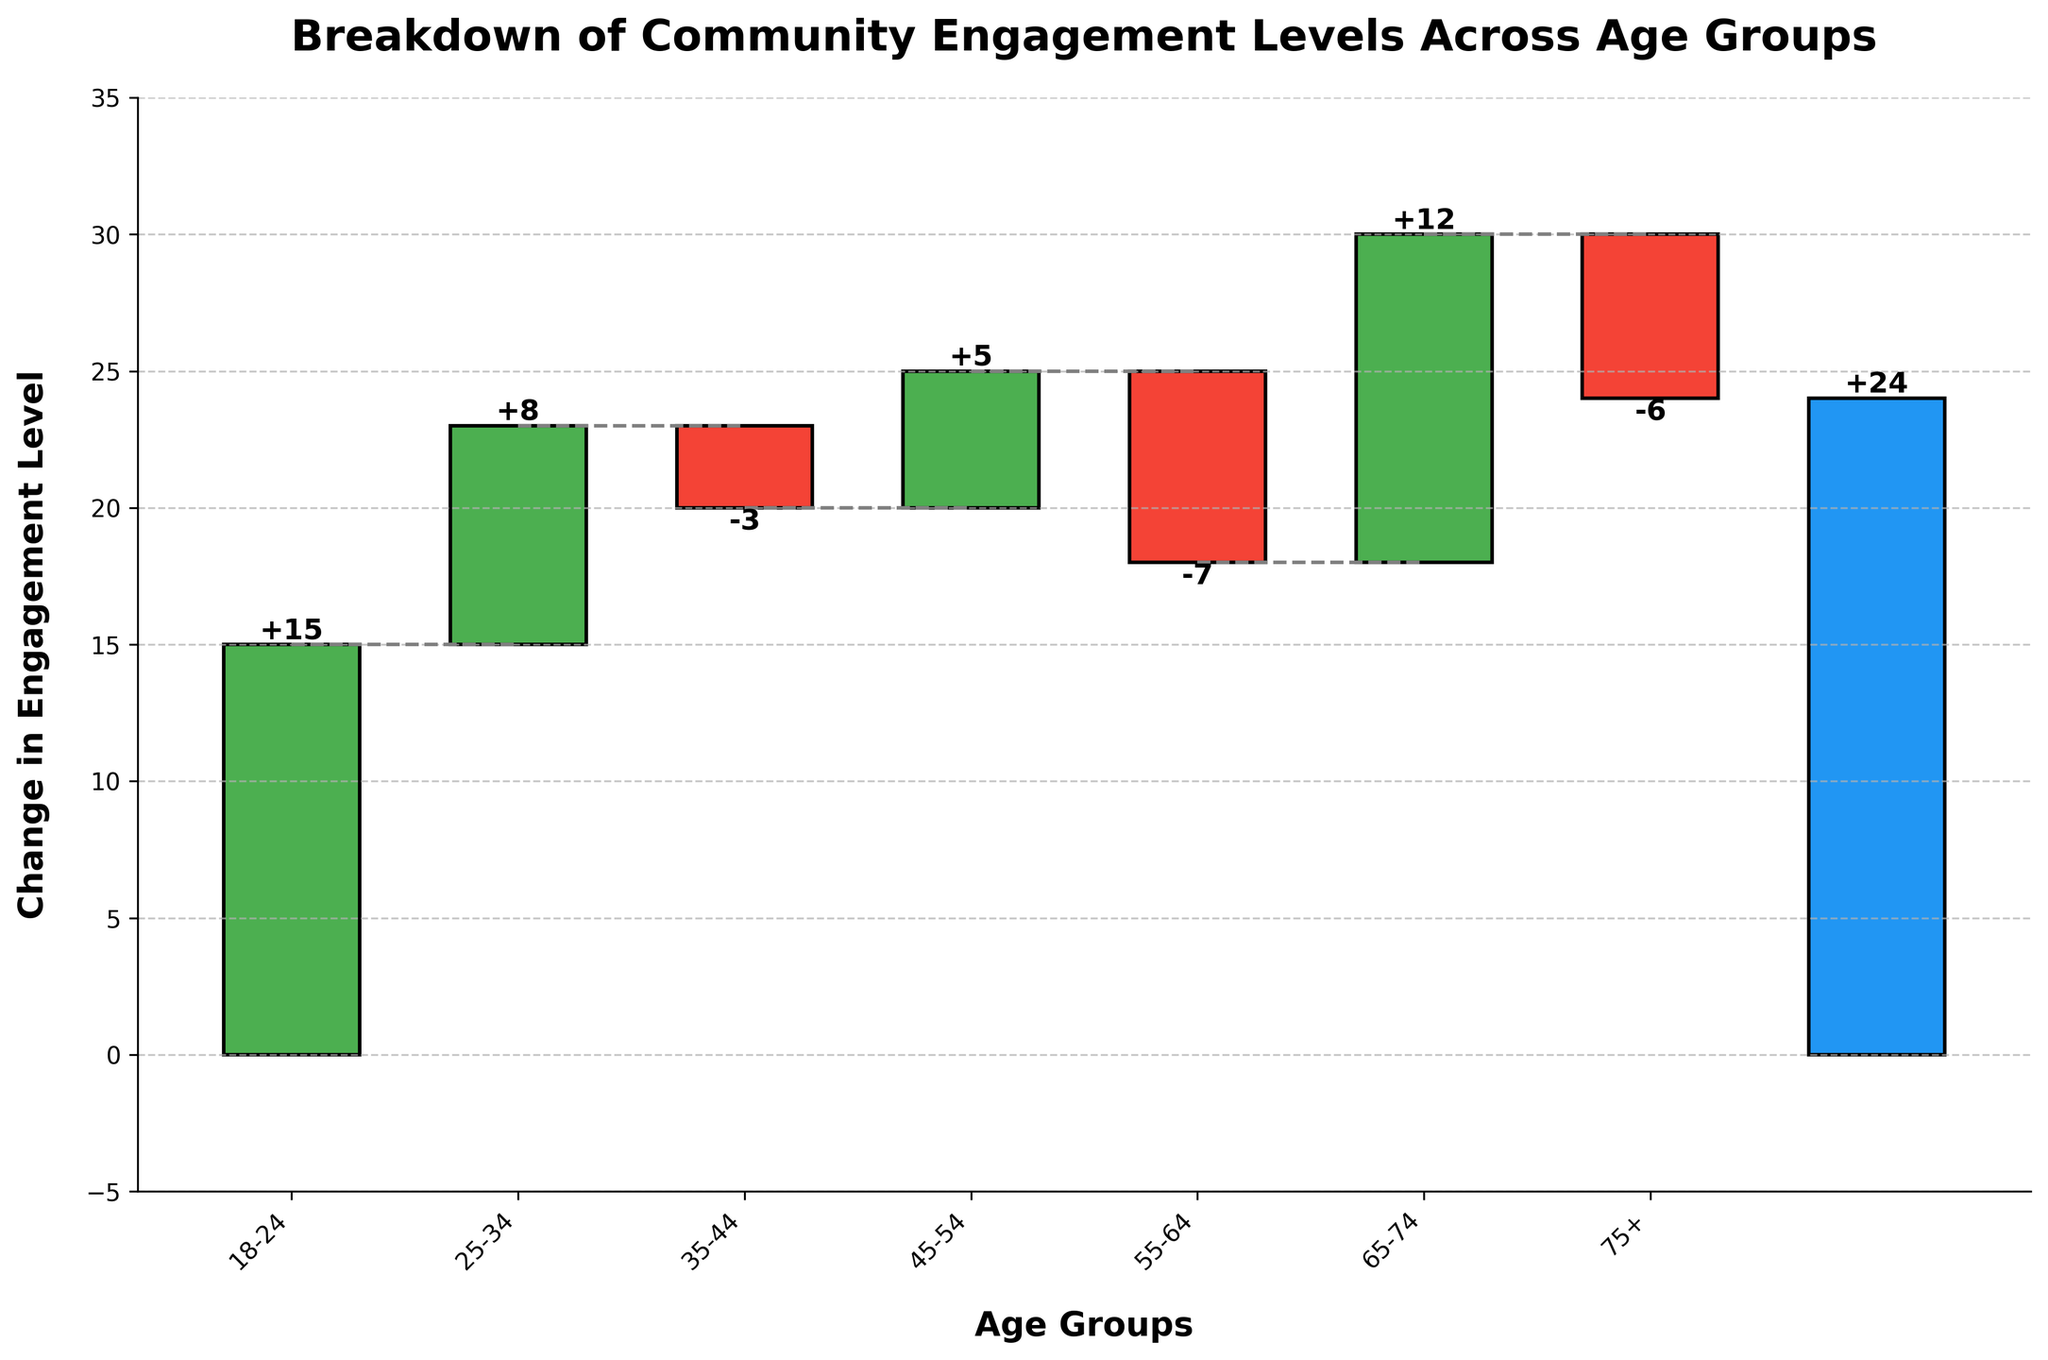What's the title of the figure? The title of the figure is displayed prominently at the top of the chart. It is 'Breakdown of Community Engagement Levels Across Age Groups'.
Answer: Breakdown of Community Engagement Levels Across Age Groups Which age group shows the highest positive change in engagement level? Look at the bars representing each age group and identify the one with the highest positive value. The '18-24' age group shows a +15 change in engagement level.
Answer: 18-24 Which age group has the largest negative change in engagement level? Find the age group with the most negative value in the bar chart. The '55-64' age group shows a -7 change in engagement level.
Answer: 55-64 What is the overall change in engagement level? The overall change is represented by a separate bar at the end of the age groups. It is labeled and displays an overall change of +24.
Answer: +24 How many age groups show a positive change in engagement level? Count the number of bars that have positive values, indicated by bars extending upwards. The age groups with positive changes are '18-24', '25-34', '45-54', and '65-74'.
Answer: 4 How many age groups show a negative change in engagement level? Count the number of bars that have negative values, indicated by bars extending downwards. The age groups with negative changes are '35-44', '55-64', and '75+'.
Answer: 3 How does the engagement level for '35-44' compare to that of '45-54'? Compare the heights and directions of the bars representing '35-44' and '45-54'. The '35-44' age group has a -3 change, whereas the '45-54' age group shows a +5 change.
Answer: The '35-44' age group has a lower change What is the cumulative change up to the '55-64' age group? Calculate the cumulative change by summing the engagement levels up to '55-64'. The changes are +15, +8, -3, +5, -7, which sum up to +18.
Answer: +18 What is the average change in engagement level across all age groups (excluding the overall change)? Add the engagement changes of all individual age groups and divide by the number of age groups. (15 + 8 - 3 + 5 - 7 + 12 - 6) / 7 = 24 / 7 ≈ 3.43.
Answer: ≈ 3.43 In which part of the chart do we see the connecting lines, and what do they represent? The connecting lines are visible between the tops of consecutive bars and indicate the cumulative change as we progress from one age group to the next. They show the sequential impact on the overall engagement level.
Answer: Between bars, showing cumulative change 